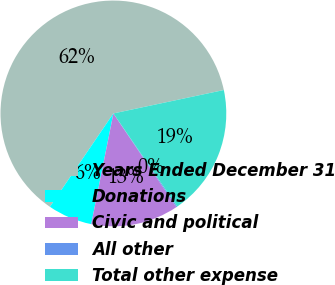<chart> <loc_0><loc_0><loc_500><loc_500><pie_chart><fcel>Years Ended December 31<fcel>Donations<fcel>Civic and political<fcel>All other<fcel>Total other expense<nl><fcel>62.17%<fcel>6.36%<fcel>12.56%<fcel>0.15%<fcel>18.76%<nl></chart> 